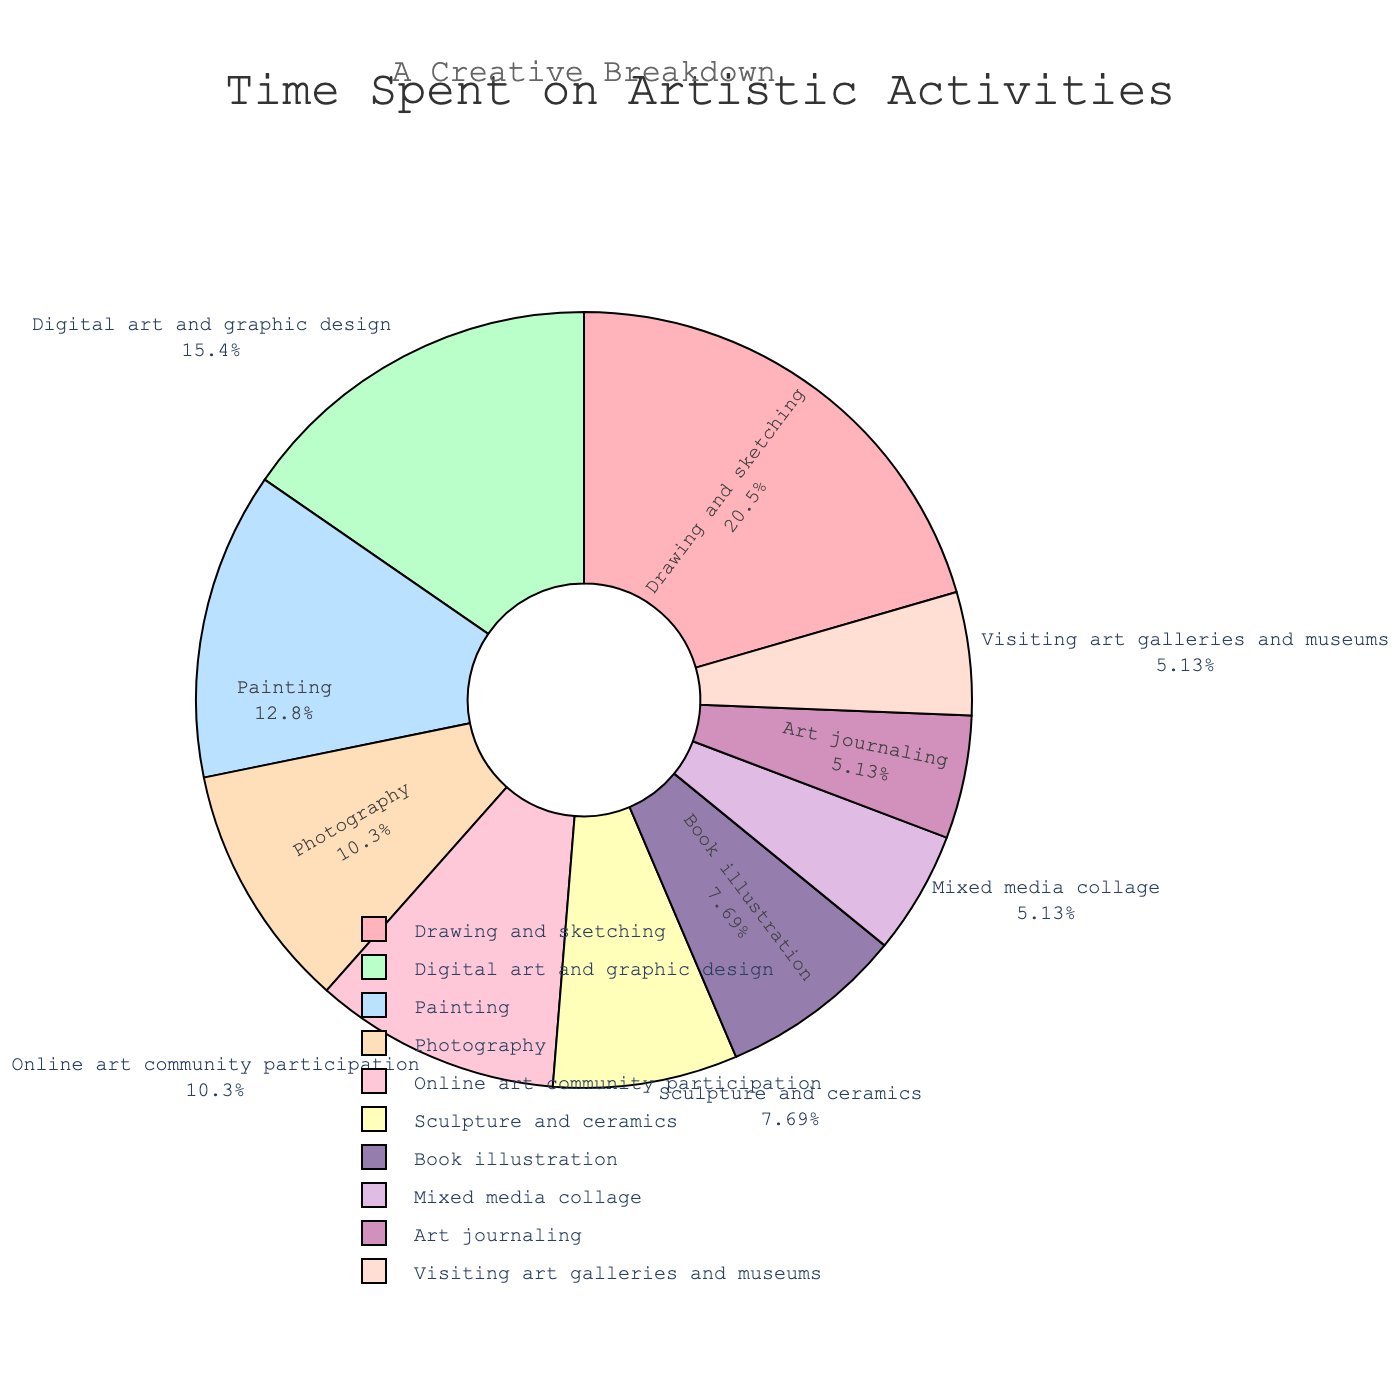What activity occupies the most time weekly? Drawing and sketching has the highest percentage. The slice representing it is the largest in the pie chart.
Answer: Drawing and sketching Which activity takes up less time, book illustration or art journaling? Book illustration takes up 3 hours per week, while art journaling takes up 2 hours per week. Thus, art journaling occupies less time.
Answer: Art journaling What is the combined percentage of time spent on digital art and graphic design and photography? Digital art and graphic design accounts for 6 hours and photography accounts for 4 hours. Together they account for 10 hours. The total hours are 39, so (10/39) * 100 ≈ 25.64%.
Answer: 25.64% Which two activities have the same time allocation? Both sculpture and ceramics, and book illustration take up 3 hours each as indicated by their equal-sized slices in the pie chart.
Answer: Sculpture and ceramics, Book illustration Is more time spent on digital art and graphic design or painting? Digital art and graphic design is allocated 6 hours per week, whereas painting is given 5 hours per week. Thus, more time is spent on digital art and graphic design.
Answer: Digital art and graphic design What is the total percentage of time spent on drawing and sketching, and painting? Drawing and sketching is 8 hours, and painting is 5 hours. Together, they make 13 hours. The total hours are 39, so (13/39) * 100 ≈ 33.33%.
Answer: 33.33% Which activity represented by a pastel pink color? The pastel pink slice represents the time spent on drawing and sketching, as indicated by its position and percentage in the pie chart.
Answer: Drawing and sketching By how many hours does the time spent on mixed media collage differ from that of online art community participation? Mixed media collage is 2 hours, and online art community participation is 4 hours. The difference is 4 - 2 = 2 hours.
Answer: 2 hours What percentage of their time do students spend on visiting art galleries and museums? Visiting art galleries and museums takes up 2 hours. The total hours are 39, so (2/39) * 100 ≈ 5.13%.
Answer: 5.13% How does the combined time for art journaling and visiting art galleries compare to the time for painting? Art journaling is 2 hours, visiting art galleries is 2 hours, combined they are 2 + 2 = 4 hours. Painting is 5 hours. 4 < 5, so the combined time is less.
Answer: Less 